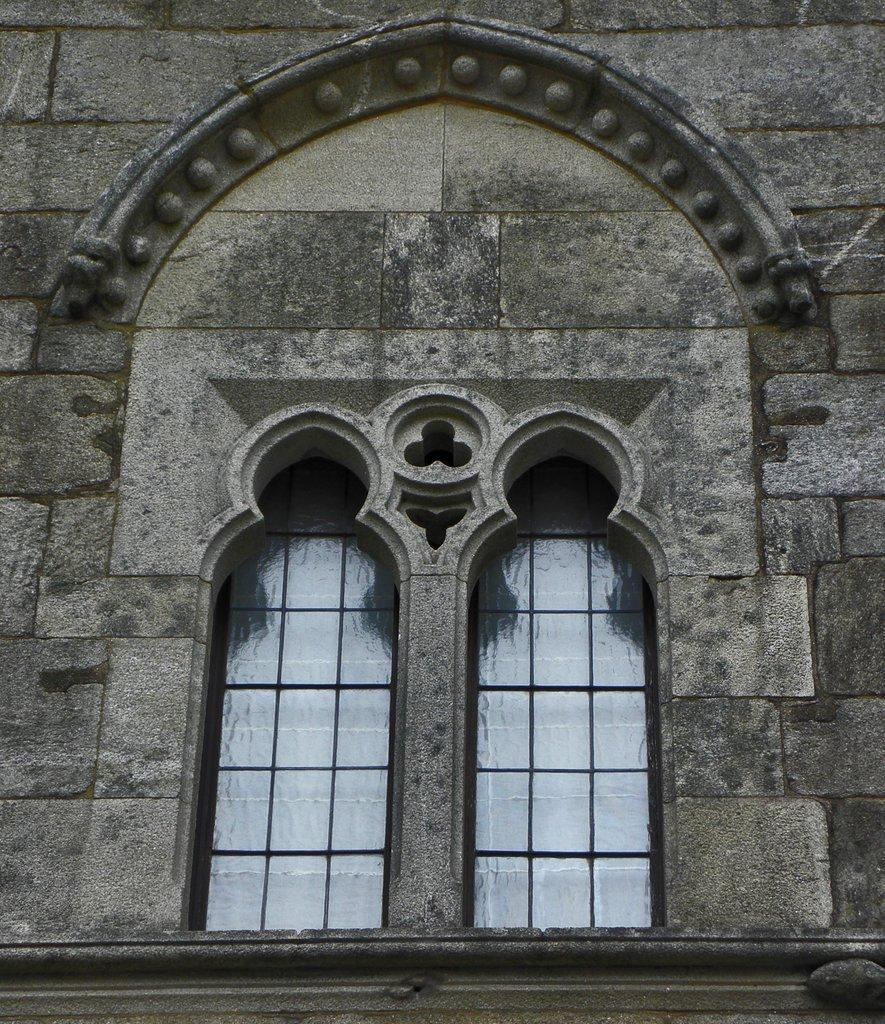What architectural feature is visible in the image? There are windows visible in the image. To which structure do the windows belong? The windows belong to a building. What type of railway can be seen passing through the building in the image? There is no railway present in the image; it only features windows belonging to a building. How does the company logo appear on the windows in the image? There is no company logo visible on the windows in the image. 